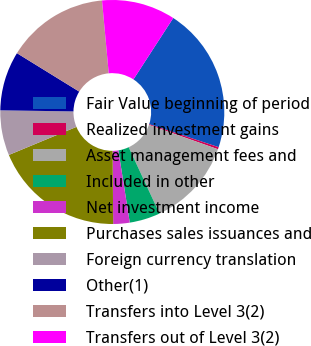Convert chart. <chart><loc_0><loc_0><loc_500><loc_500><pie_chart><fcel>Fair Value beginning of period<fcel>Realized investment gains<fcel>Asset management fees and<fcel>Included in other<fcel>Net investment income<fcel>Purchases sales issuances and<fcel>Foreign currency translation<fcel>Other(1)<fcel>Transfers into Level 3(2)<fcel>Transfers out of Level 3(2)<nl><fcel>20.93%<fcel>0.31%<fcel>12.68%<fcel>4.43%<fcel>2.37%<fcel>18.86%<fcel>6.5%<fcel>8.56%<fcel>14.74%<fcel>10.62%<nl></chart> 